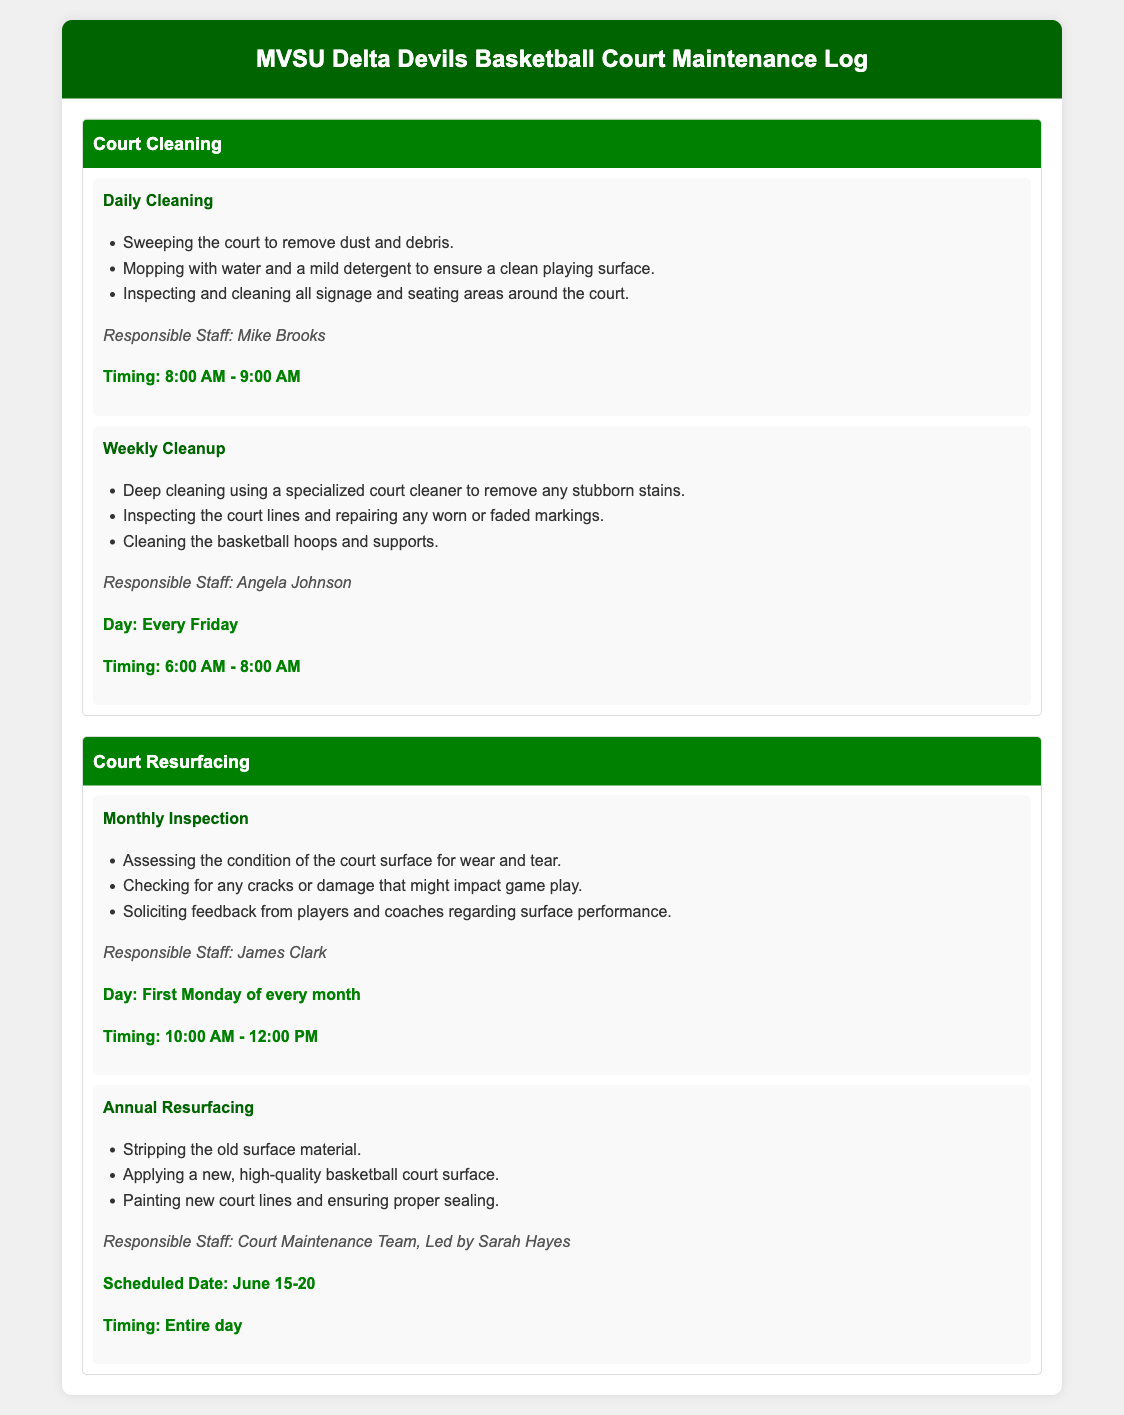what time is daily cleaning scheduled? The daily cleaning is scheduled from 8:00 AM to 9:00 AM, as stated in the document.
Answer: 8:00 AM - 9:00 AM who is responsible for weekly cleanup? The document indicates that Angela Johnson is responsible for the weekly cleanup.
Answer: Angela Johnson when is the monthly inspection conducted? According to the document, the monthly inspection is held on the first Monday of every month.
Answer: First Monday of every month what is the scheduled date for annual resurfacing? The document specifies that the annual resurfacing is scheduled from June 15 to June 20.
Answer: June 15-20 what staff member leads the court maintenance team? The document mentions that Sarah Hayes leads the court maintenance team.
Answer: Sarah Hayes how often is deep cleaning performed? The document states that a deep cleaning is performed weekly.
Answer: Every Friday what is included in daily cleaning? The document lists several tasks for daily cleaning, including sweeping and mopping the court.
Answer: Sweeping, mopping how long does the annual resurfacing take? The document does not specify hours but indicates that the resurfacing is an all-day event.
Answer: Entire day what type of cleaning solution is used for weekly cleanup? Weekly cleanup employs a specialized court cleaner to address stubborn stains.
Answer: Specialized court cleaner 